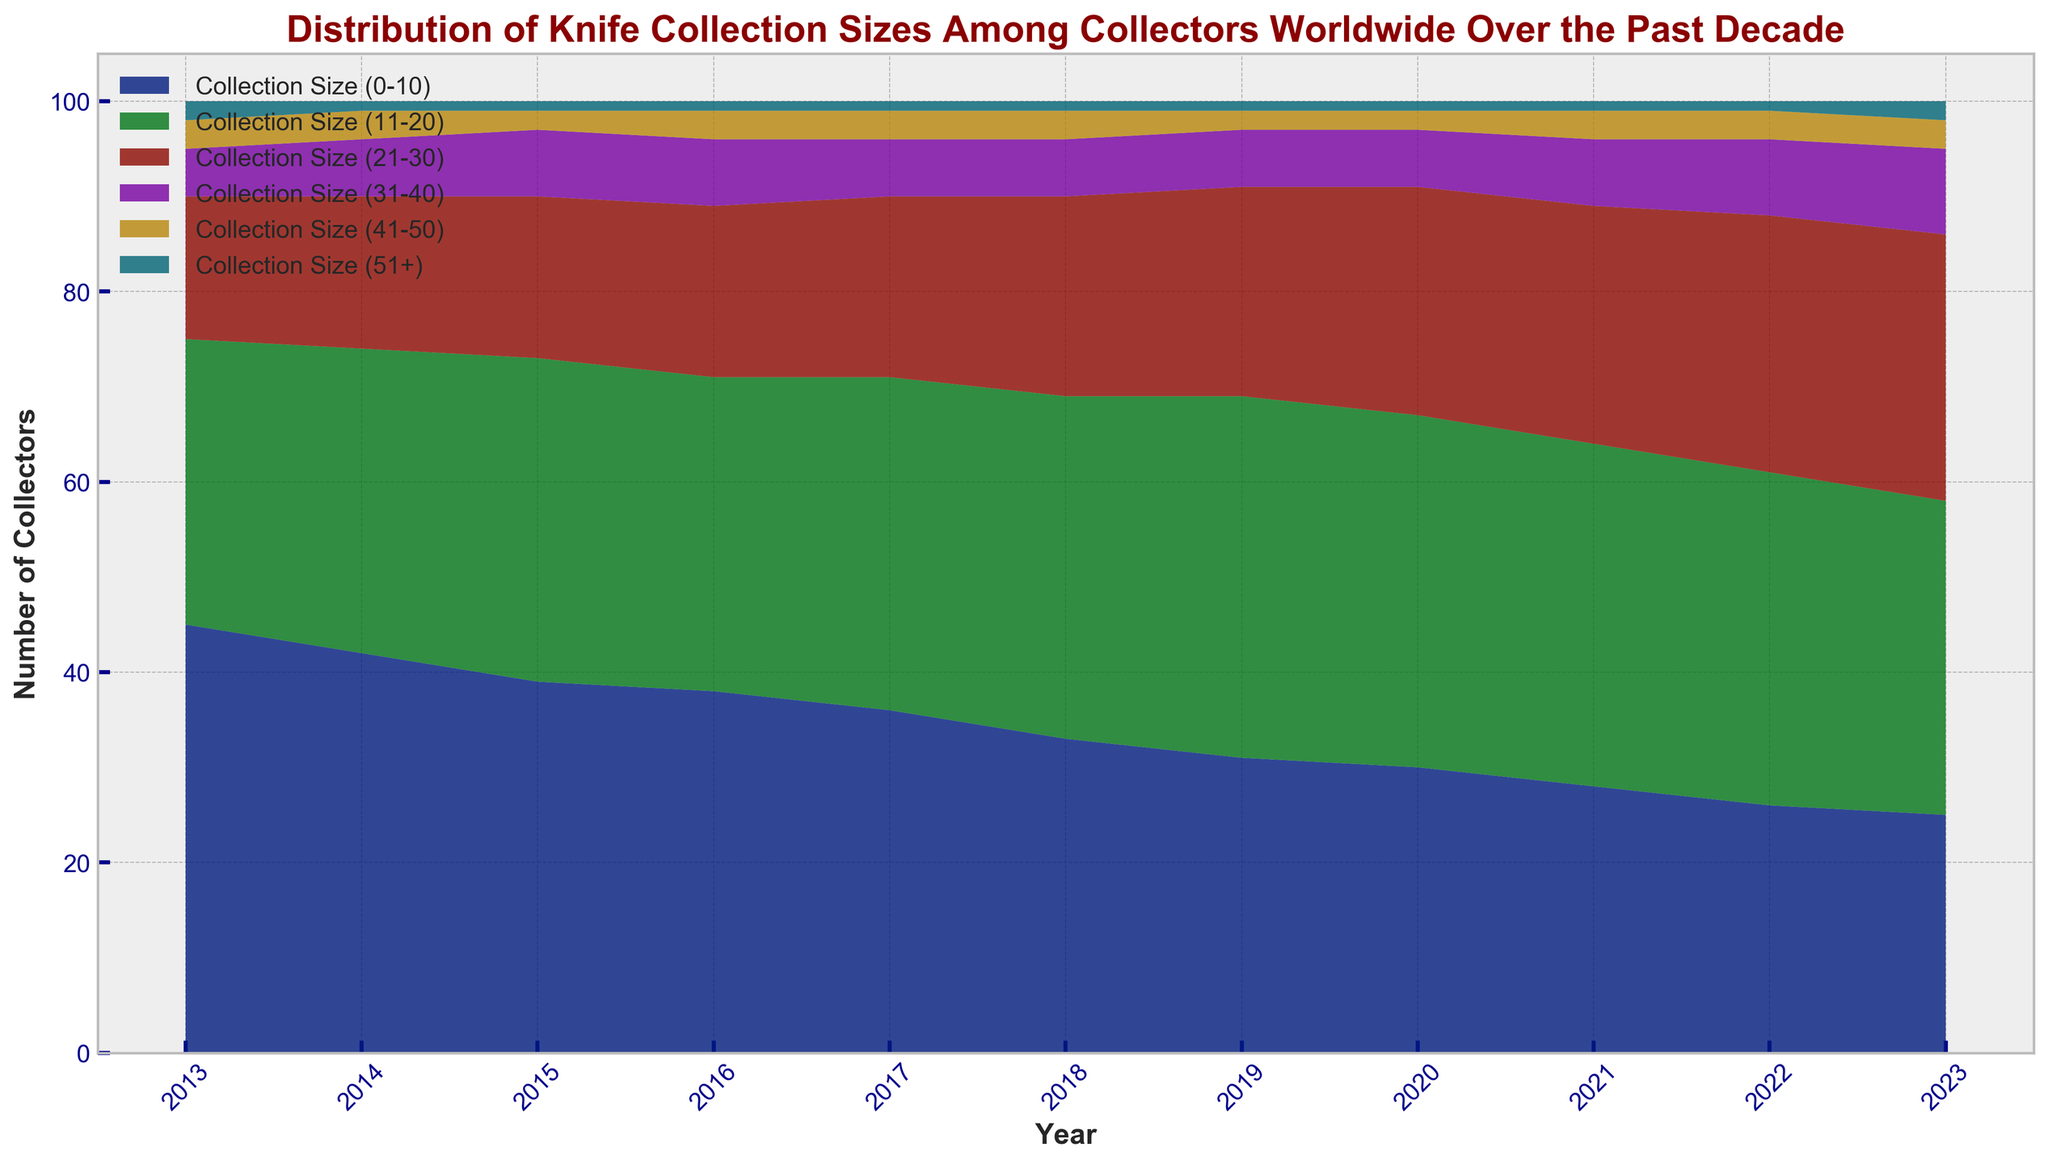Which year had the highest number of collectors with collection sizes between 21-30? To find this, look at the "Collection Size (21-30)" category across all years and identify the year with the highest value. The peak in the area representing the 21-30 collection size on the chart occurs in 2023.
Answer: 2023 How did the number of collectors with collection sizes between 0-10 change from 2013 to 2023? Look at the "Collection Size (0-10)" category for both 2013 and 2023. In 2013, the value is 45, and in 2023, the value is 25. Subtract the 2023 value from the 2013 value to see the change. 45 - 25 = 20.
Answer: Decreased by 20 Which collection size category had its peak number of collectors in 2018? Identify the peaks for each category in 2018. "Collection Size (0-10)" is 33, "Collection Size (11-20)" is 36, "Collection Size (21-30)" is 21, "Collection Size (31-40)" is 6, "Collection Size (41-50)" is 3, and "Collection Size (51+)" is 1. The highest peak in 2018 is for the "Collection Size (11-20)" category.
Answer: Collection Size (11-20) In which year did the "Collection Size (11-20)" category have a smaller number than in the previous year? Examine the "Collection Size (11-20)" values year by year. The number decreases from 38 in 2019 to 37 in 2020.
Answer: 2020 Compare the number of collectors with collection sizes of 41-50 in 2013 and 2023. Which year had more and by how much? Look at the "Collection Size (41-50)" values for both 2013 and 2023. For 2013, the value is 3 collectors, and for 2023, it is also 3. Subtract the smaller value from the larger value: 3 - 3 = 0.
Answer: No difference What is the difference in the number of collectors with collection sizes over 51 between 2013 and 2023? Look at the "Collection Size (51+)" values for both 2013 and 2023. In 2013, it is 2, and in 2023, it is also 2. Subtract the 2013 value from the 2023 value: 2 - 2 = 0.
Answer: No difference Which collection size category shows the most significant increase in collectors from 2013 to 2023? Examine the changes for each category from 2013 to 2023. "Collection Size (0-10)" decreases from 45 to 25 by -20, "Collection Size (11-20)" increases from 30 to 33 by +3, "Collection Size (21-30)" increases from 15 to 28 by +13, "Collection Size (31-40)" increases from 5 to 9 by +4, "Collection Size (41-50)" stays the same, and "Collection Size (51+)" increases by 0. The "Collection Size (21-30)" category has the highest increase of +13.
Answer: Collection Size (21-30) How did the combined number of collectors with collection sizes between 31 and 50 change from 2021 to 2023? Look at the sum of "Collection Size (31-40)" and "Collection Size (41-50)" for both years. For 2021: 7 + 3 = 10. For 2023: 9 + 3 = 12. Subtract the 2021 value from the 2023 value: 12 - 10 = 2.
Answer: Increased by 2 What's the total number of collectors in 2015? Sum all the collection size categories for 2015: 39, 34, 17, 7, 2, and 1. 39 + 34 + 17 + 7 + 2 + 1 = 100.
Answer: 100 